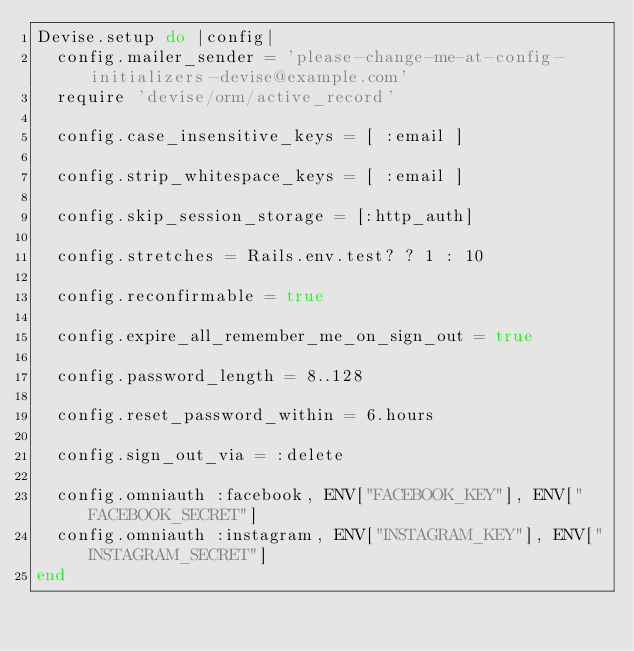<code> <loc_0><loc_0><loc_500><loc_500><_Ruby_>Devise.setup do |config|
  config.mailer_sender = 'please-change-me-at-config-initializers-devise@example.com'
  require 'devise/orm/active_record'
  
  config.case_insensitive_keys = [ :email ]
  
  config.strip_whitespace_keys = [ :email ]
  
  config.skip_session_storage = [:http_auth]
  
  config.stretches = Rails.env.test? ? 1 : 10
  
  config.reconfirmable = true
  
  config.expire_all_remember_me_on_sign_out = true
  
  config.password_length = 8..128
  
  config.reset_password_within = 6.hours
  
  config.sign_out_via = :delete

  config.omniauth :facebook, ENV["FACEBOOK_KEY"], ENV["FACEBOOK_SECRET"]
  config.omniauth :instagram, ENV["INSTAGRAM_KEY"], ENV["INSTAGRAM_SECRET"]
end
</code> 